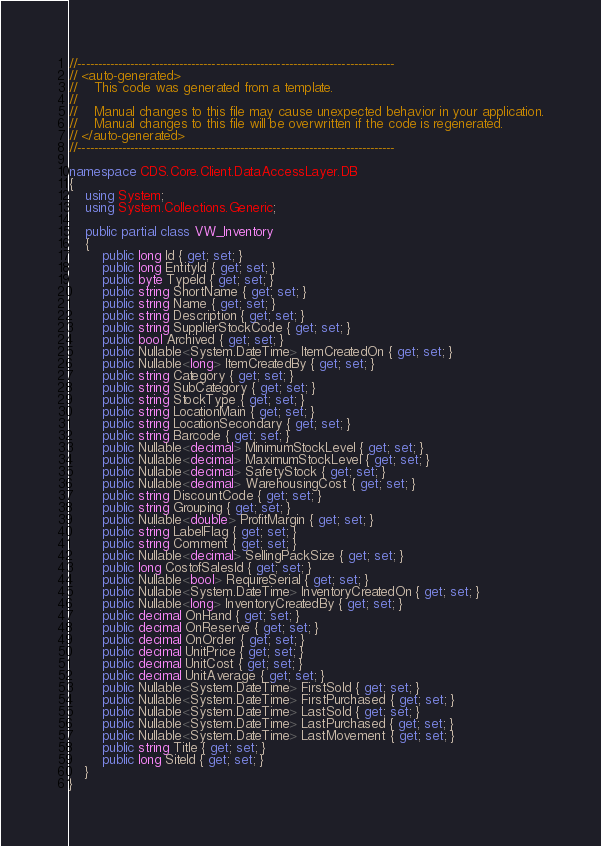Convert code to text. <code><loc_0><loc_0><loc_500><loc_500><_C#_>//------------------------------------------------------------------------------
// <auto-generated>
//    This code was generated from a template.
//
//    Manual changes to this file may cause unexpected behavior in your application.
//    Manual changes to this file will be overwritten if the code is regenerated.
// </auto-generated>
//------------------------------------------------------------------------------

namespace CDS.Core.Client.DataAccessLayer.DB
{
    using System;
    using System.Collections.Generic;
    
    public partial class VW_Inventory
    {
        public long Id { get; set; }
        public long EntityId { get; set; }
        public byte TypeId { get; set; }
        public string ShortName { get; set; }
        public string Name { get; set; }
        public string Description { get; set; }
        public string SupplierStockCode { get; set; }
        public bool Archived { get; set; }
        public Nullable<System.DateTime> ItemCreatedOn { get; set; }
        public Nullable<long> ItemCreatedBy { get; set; }
        public string Category { get; set; }
        public string SubCategory { get; set; }
        public string StockType { get; set; }
        public string LocationMain { get; set; }
        public string LocationSecondary { get; set; }
        public string Barcode { get; set; }
        public Nullable<decimal> MinimumStockLevel { get; set; }
        public Nullable<decimal> MaximumStockLevel { get; set; }
        public Nullable<decimal> SafetyStock { get; set; }
        public Nullable<decimal> WarehousingCost { get; set; }
        public string DiscountCode { get; set; }
        public string Grouping { get; set; }
        public Nullable<double> ProfitMargin { get; set; }
        public string LabelFlag { get; set; }
        public string Comment { get; set; }
        public Nullable<decimal> SellingPackSize { get; set; }
        public long CostofSalesId { get; set; }
        public Nullable<bool> RequireSerial { get; set; }
        public Nullable<System.DateTime> InventoryCreatedOn { get; set; }
        public Nullable<long> InventoryCreatedBy { get; set; }
        public decimal OnHand { get; set; }
        public decimal OnReserve { get; set; }
        public decimal OnOrder { get; set; }
        public decimal UnitPrice { get; set; }
        public decimal UnitCost { get; set; }
        public decimal UnitAverage { get; set; }
        public Nullable<System.DateTime> FirstSold { get; set; }
        public Nullable<System.DateTime> FirstPurchased { get; set; }
        public Nullable<System.DateTime> LastSold { get; set; }
        public Nullable<System.DateTime> LastPurchased { get; set; }
        public Nullable<System.DateTime> LastMovement { get; set; }
        public string Title { get; set; }
        public long SiteId { get; set; }
    }
}
</code> 